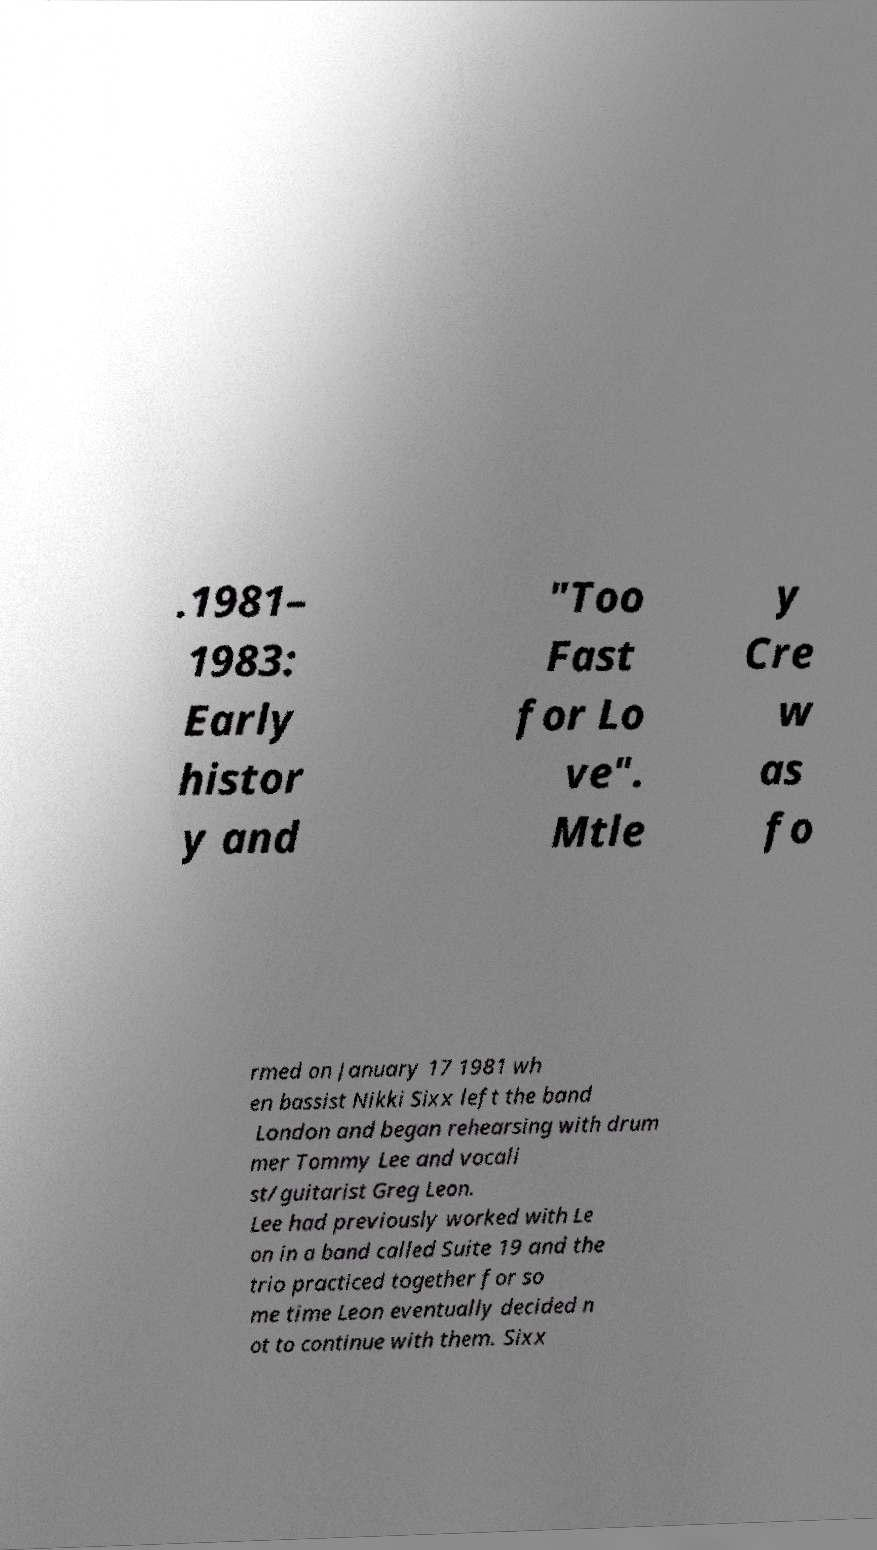For documentation purposes, I need the text within this image transcribed. Could you provide that? .1981– 1983: Early histor y and "Too Fast for Lo ve". Mtle y Cre w as fo rmed on January 17 1981 wh en bassist Nikki Sixx left the band London and began rehearsing with drum mer Tommy Lee and vocali st/guitarist Greg Leon. Lee had previously worked with Le on in a band called Suite 19 and the trio practiced together for so me time Leon eventually decided n ot to continue with them. Sixx 